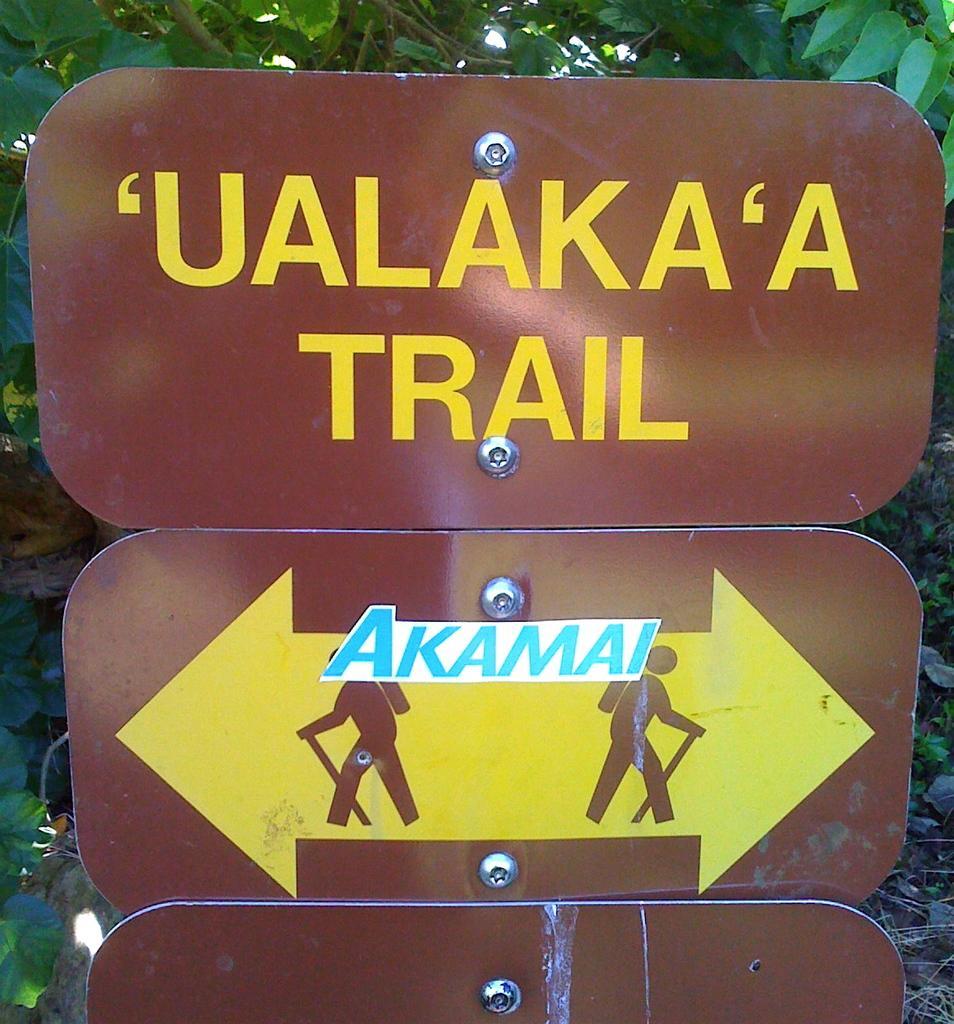In one or two sentences, can you explain what this image depicts? In this picture we can see three boards with the screws. On the boards, it is written something. Behind the boards, there are trees. 